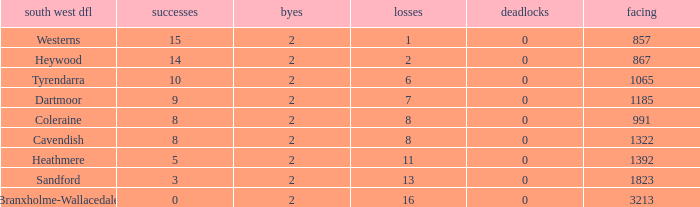Which Losses have a South West DFL of branxholme-wallacedale, and less than 2 Byes? None. 